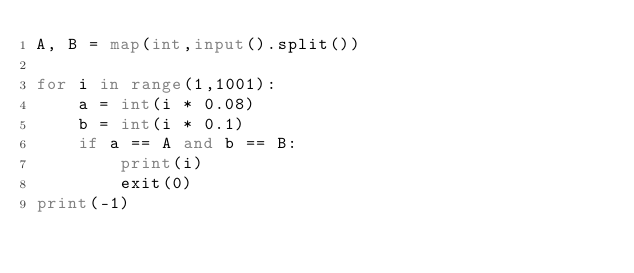<code> <loc_0><loc_0><loc_500><loc_500><_Python_>A, B = map(int,input().split())

for i in range(1,1001):
    a = int(i * 0.08)
    b = int(i * 0.1)
    if a == A and b == B:
        print(i)
        exit(0)
print(-1)</code> 